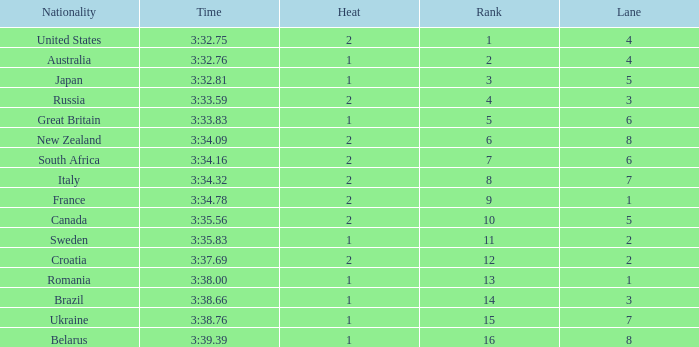Can you tell me the Time that has the Heat of 1, and the Lane of 2? 3:35.83. Would you be able to parse every entry in this table? {'header': ['Nationality', 'Time', 'Heat', 'Rank', 'Lane'], 'rows': [['United States', '3:32.75', '2', '1', '4'], ['Australia', '3:32.76', '1', '2', '4'], ['Japan', '3:32.81', '1', '3', '5'], ['Russia', '3:33.59', '2', '4', '3'], ['Great Britain', '3:33.83', '1', '5', '6'], ['New Zealand', '3:34.09', '2', '6', '8'], ['South Africa', '3:34.16', '2', '7', '6'], ['Italy', '3:34.32', '2', '8', '7'], ['France', '3:34.78', '2', '9', '1'], ['Canada', '3:35.56', '2', '10', '5'], ['Sweden', '3:35.83', '1', '11', '2'], ['Croatia', '3:37.69', '2', '12', '2'], ['Romania', '3:38.00', '1', '13', '1'], ['Brazil', '3:38.66', '1', '14', '3'], ['Ukraine', '3:38.76', '1', '15', '7'], ['Belarus', '3:39.39', '1', '16', '8']]} 